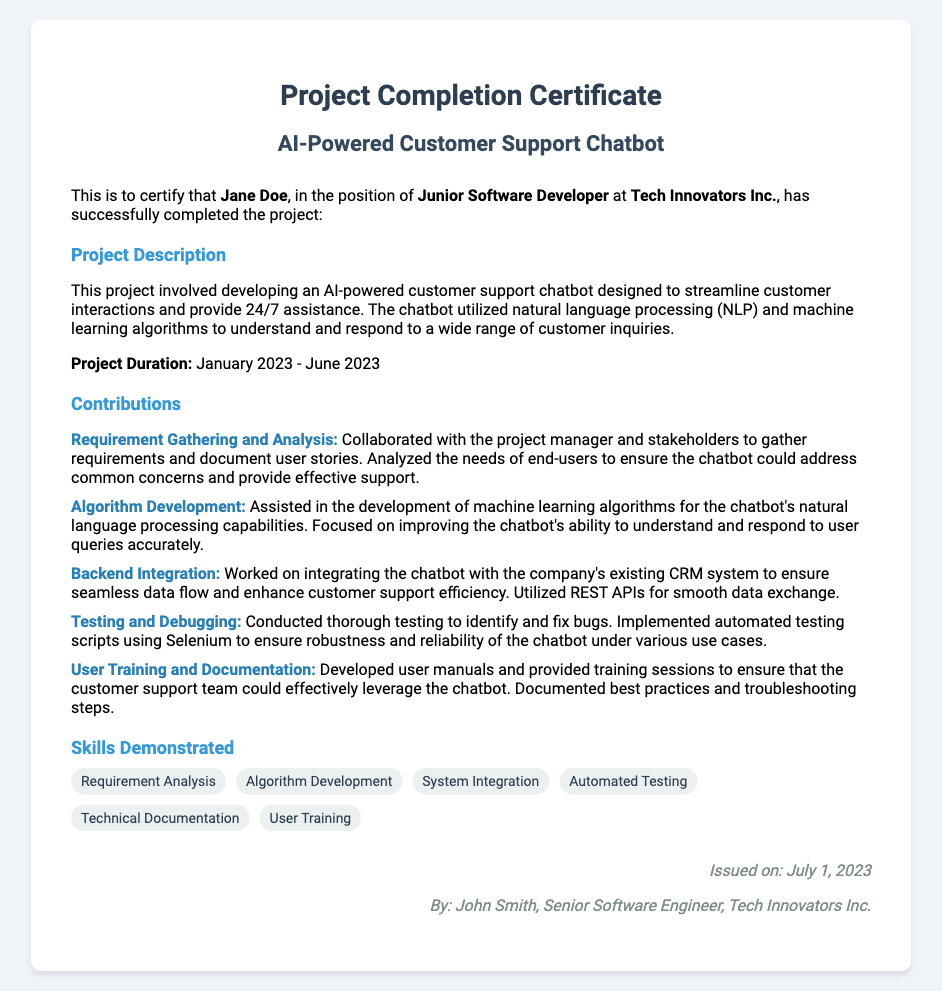What is the project title? The project title is stated in the header section of the document.
Answer: AI-Powered Customer Support Chatbot Who is the employee's name? The employee's name is mentioned in the introduction of the document.
Answer: Jane Doe What was the project duration? The project duration is specified in the project description section.
Answer: January 2023 - June 2023 Who issued the certificate? The issuer's name is mentioned in the footer of the document.
Answer: John Smith How many tasks did Jane Doe contribute to? The contributions section lists the specific tasks completed by Jane Doe.
Answer: Five What skill is related to gathering user requirements? The skills demonstrated section highlights various skills, including one specifically about requirements.
Answer: Requirement Analysis What integration work did Jane Doe perform? The contributions section details one of the tasks related to system integration.
Answer: Backend Integration What testing method was used by Jane Doe? The contributions section mentions the specific tool used for testing scripts.
Answer: Selenium What position did Jane Doe hold? The introduction of the document specifies Jane Doe's job position.
Answer: Junior Software Developer 